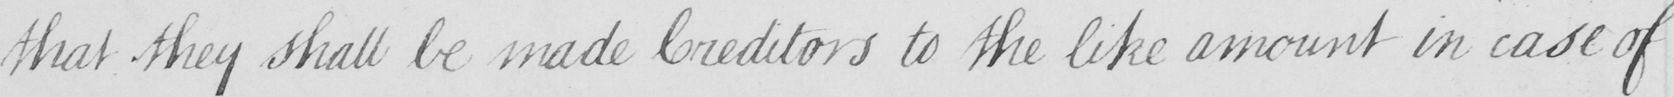Can you tell me what this handwritten text says? that they shall be made Creditors to the like amount in case of 